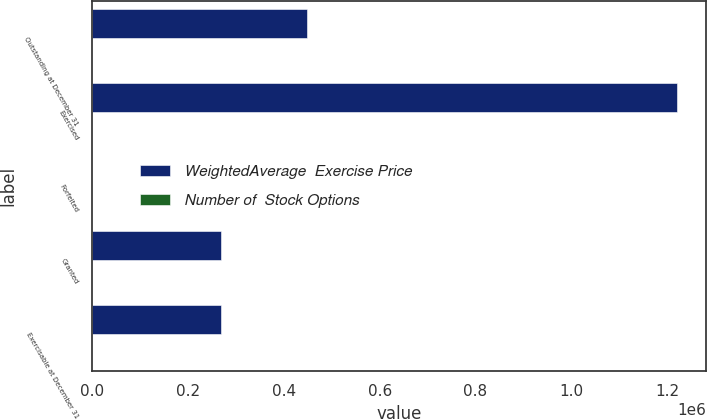Convert chart to OTSL. <chart><loc_0><loc_0><loc_500><loc_500><stacked_bar_chart><ecel><fcel>Outstanding at December 31<fcel>Exercised<fcel>Forfeited<fcel>Granted<fcel>Exercisable at December 31<nl><fcel>WeightedAverage  Exercise Price<fcel>447716<fcel>1.21982e+06<fcel>296<fcel>268817<fcel>268504<nl><fcel>Number of  Stock Options<fcel>49.19<fcel>34<fcel>23.31<fcel>66.68<fcel>37.51<nl></chart> 